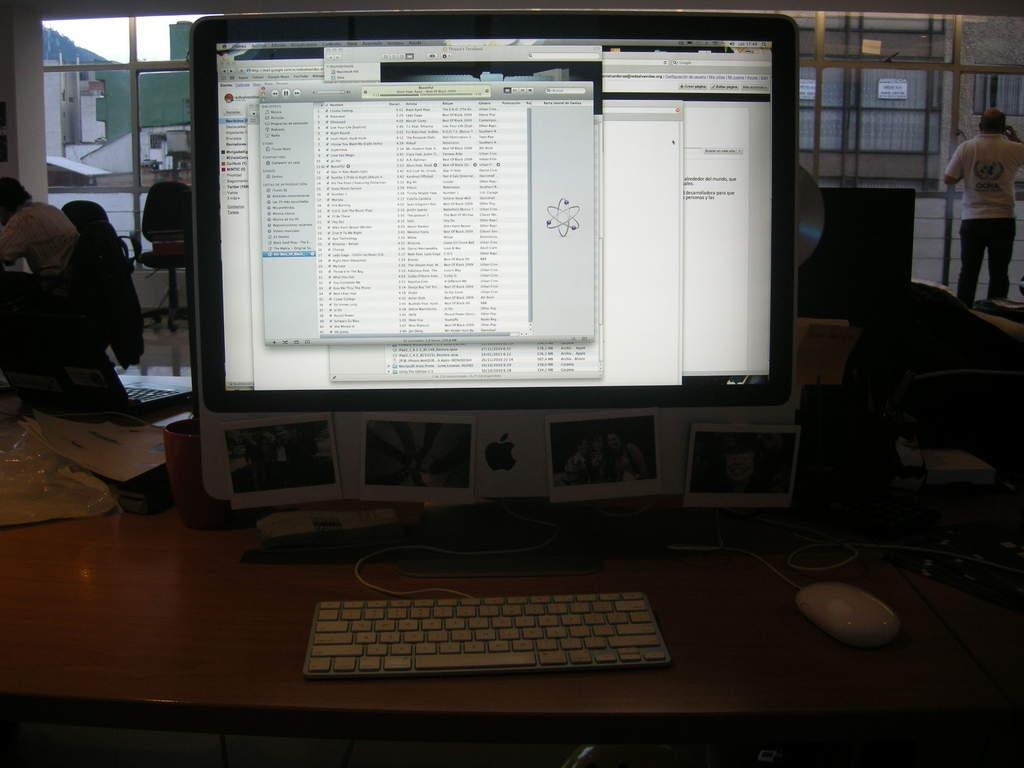<image>
Offer a succinct explanation of the picture presented. An Apple computer on a table with a screen open with an atom logo. 